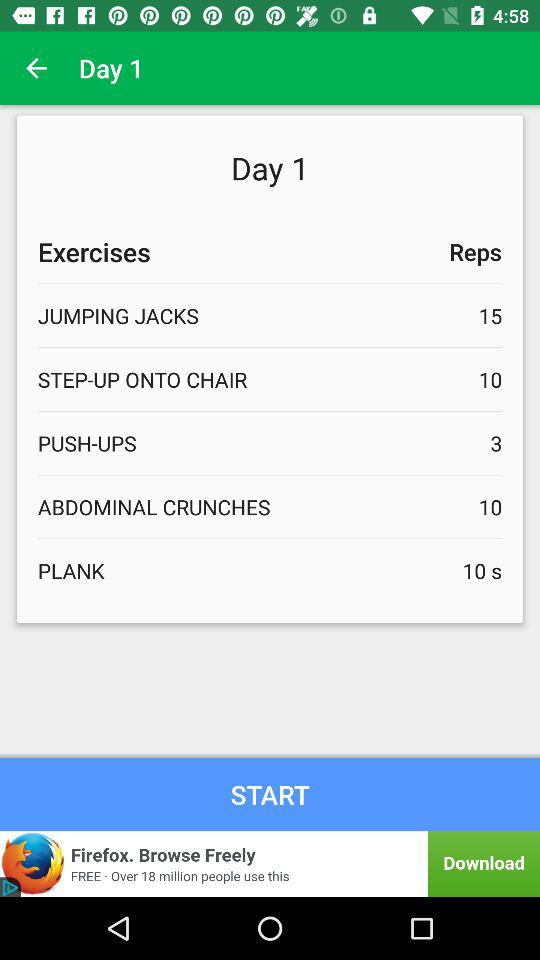How many reps are there for "ABDOMINAL CRUNCHES" on day 1? There are 10 reps. 